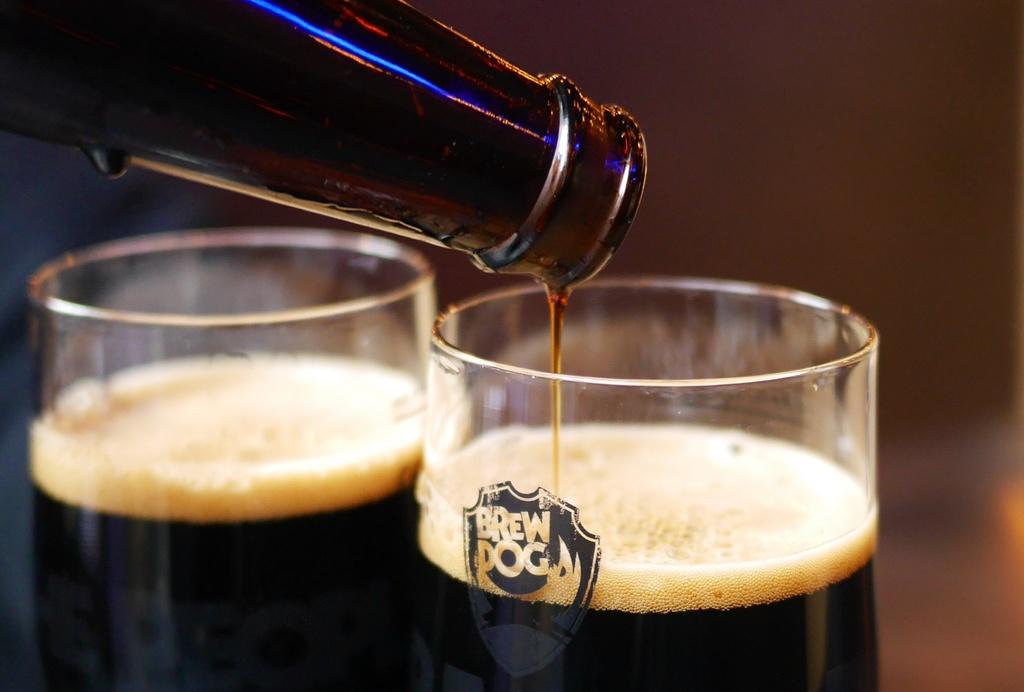What kind of beer is this?
Your answer should be compact. Brew dog. This is drinks?
Provide a short and direct response. Answering does not require reading text in the image. 